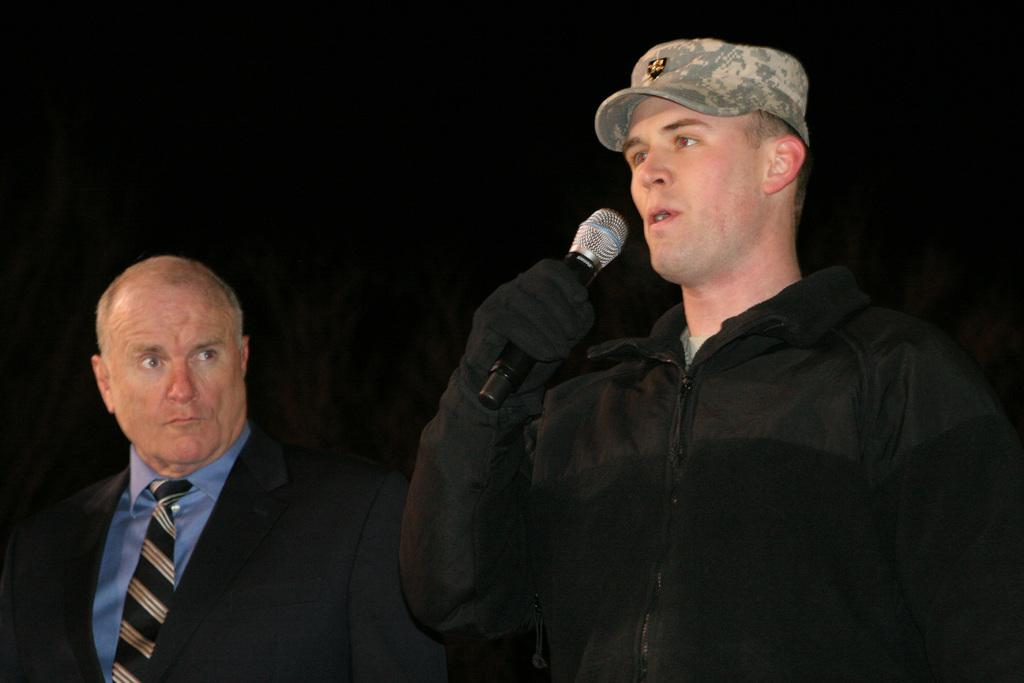How many people are in the image? There are two men in the image. What is one of the men wearing? One of the men is wearing a cap. What is the man wearing a cap holding in his hand? The man wearing a cap is holding a mic in his hand. What can be observed about the background of the image? The background of the image is dark. What type of lift is being used by the man wearing a cap in the image? There is no lift present in the image; the man wearing a cap is holding a mic in his hand. Can you tell me how many cribs are visible in the image? There are no cribs present in the image. 